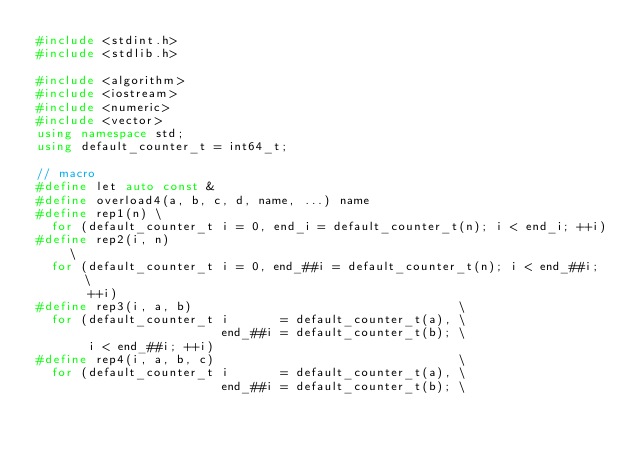Convert code to text. <code><loc_0><loc_0><loc_500><loc_500><_C++_>#include <stdint.h>
#include <stdlib.h>

#include <algorithm>
#include <iostream>
#include <numeric>
#include <vector>
using namespace std;
using default_counter_t = int64_t;

// macro
#define let auto const &
#define overload4(a, b, c, d, name, ...) name
#define rep1(n) \
  for (default_counter_t i = 0, end_i = default_counter_t(n); i < end_i; ++i)
#define rep2(i, n)                                                           \
  for (default_counter_t i = 0, end_##i = default_counter_t(n); i < end_##i; \
       ++i)
#define rep3(i, a, b)                                    \
  for (default_counter_t i       = default_counter_t(a), \
                         end_##i = default_counter_t(b); \
       i < end_##i; ++i)
#define rep4(i, a, b, c)                                 \
  for (default_counter_t i       = default_counter_t(a), \
                         end_##i = default_counter_t(b); \</code> 